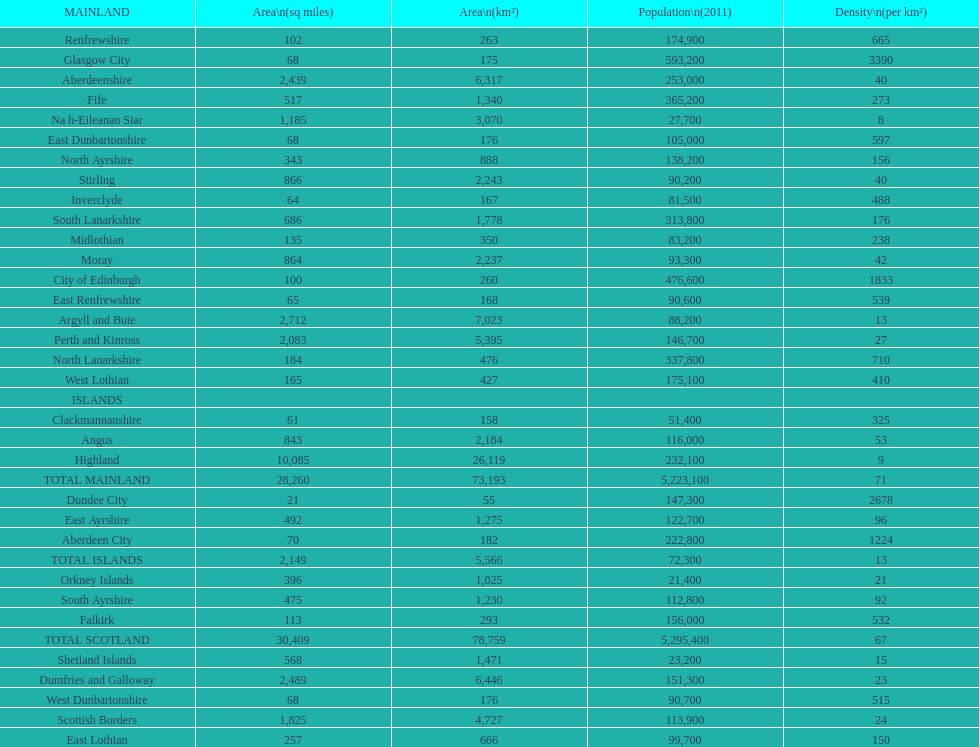Which is the only subdivision to have a greater area than argyll and bute? Highland. 